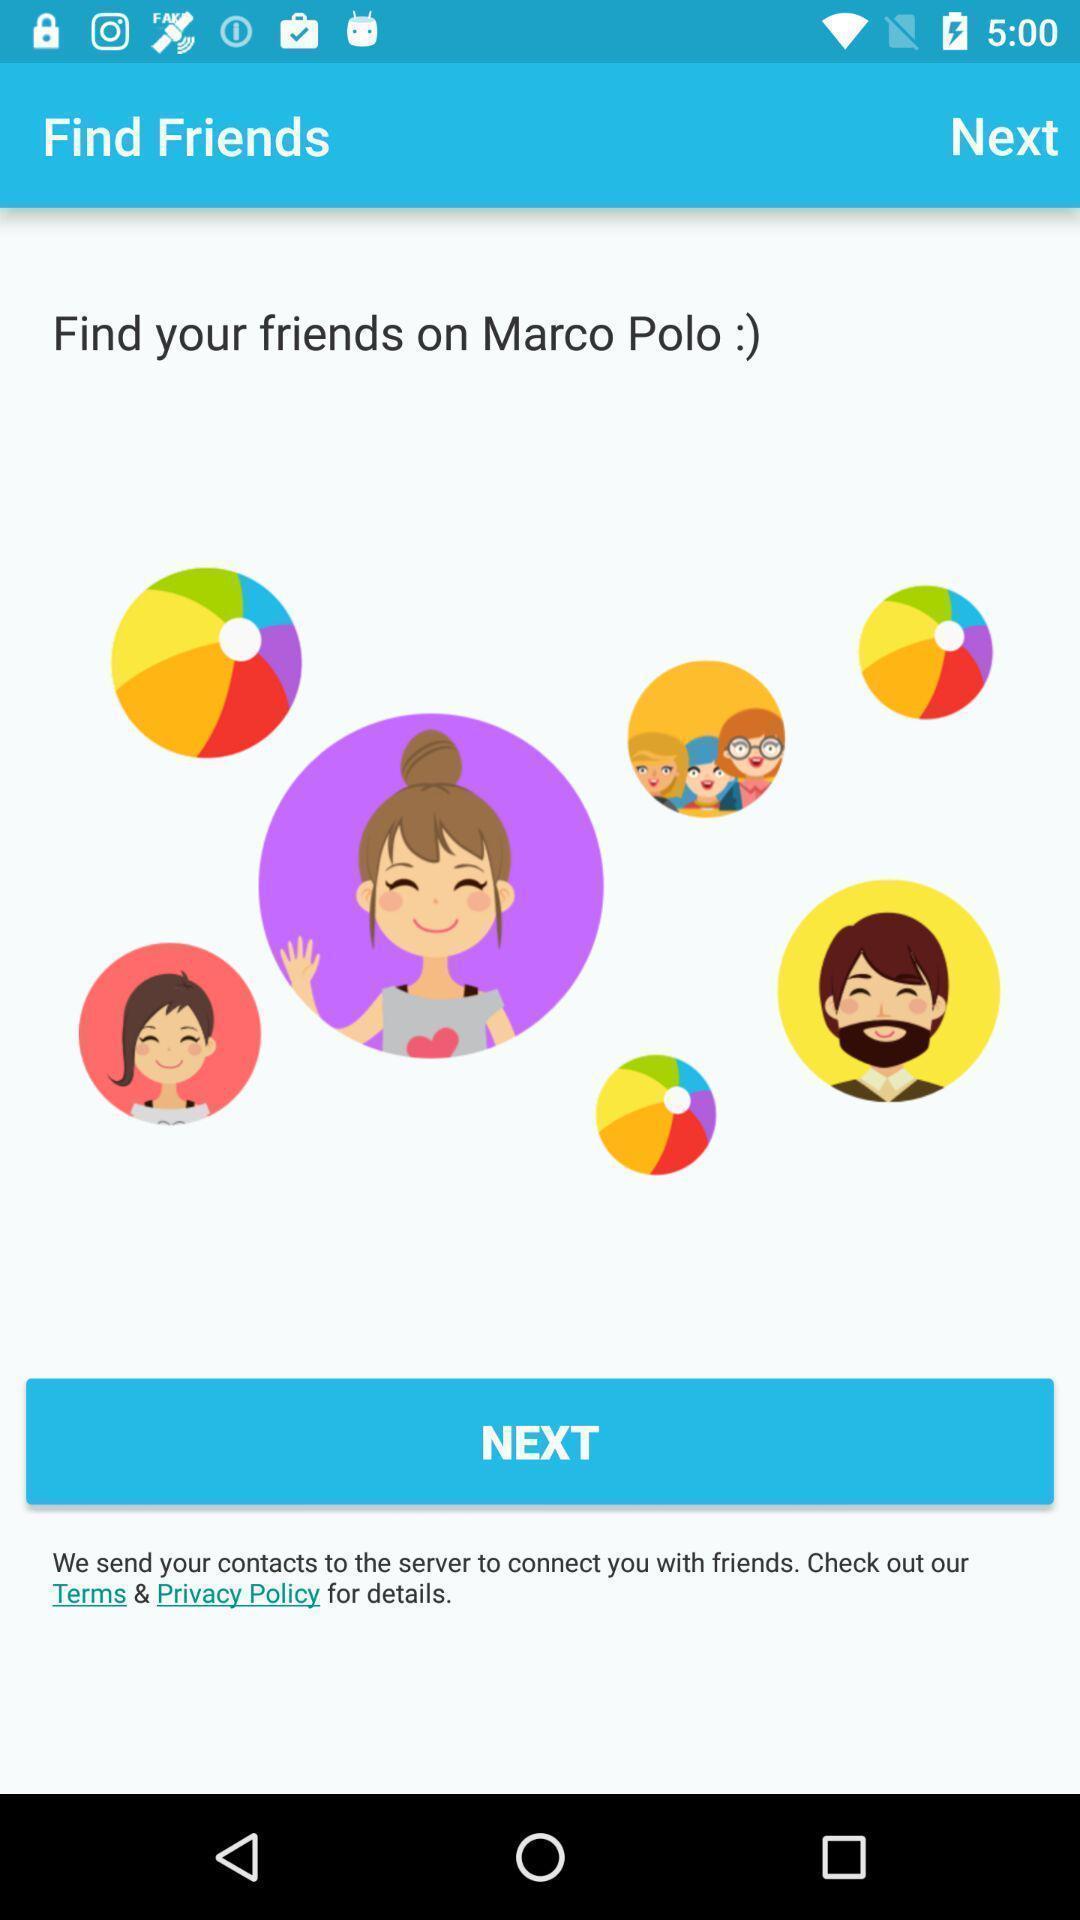What is the overall content of this screenshot? Page showing options of finding friends. 